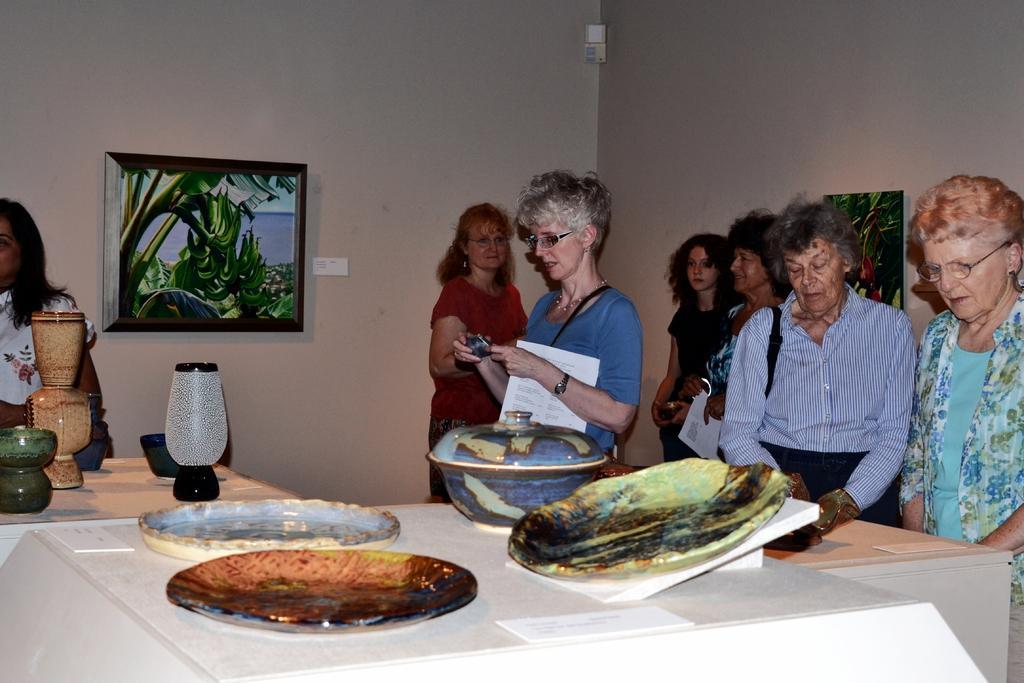Describe this image in one or two sentences. In this image there are group of persons standing and at the foreground of the image there are some plates and dish boxes on top of the table and at the background of the image there are paintings attached to the wall. 